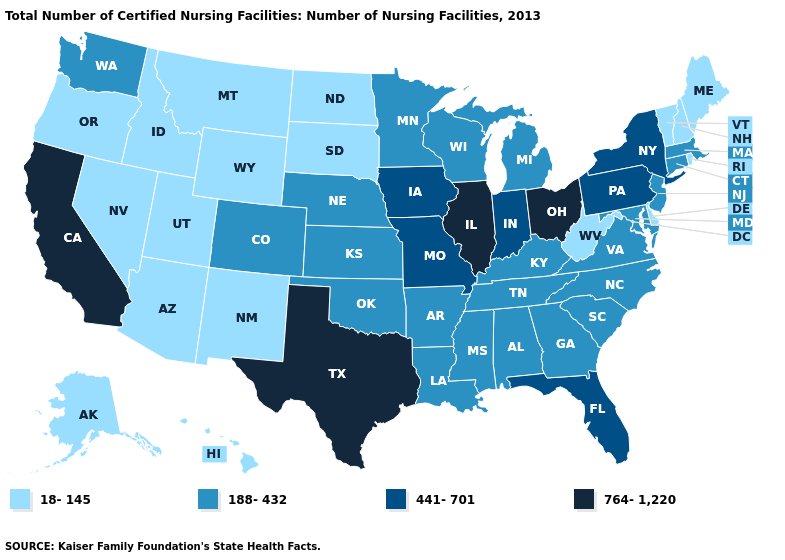What is the value of Rhode Island?
Keep it brief. 18-145. Which states have the lowest value in the Northeast?
Concise answer only. Maine, New Hampshire, Rhode Island, Vermont. Does the first symbol in the legend represent the smallest category?
Concise answer only. Yes. Does Maine have a lower value than Oregon?
Give a very brief answer. No. What is the highest value in the USA?
Answer briefly. 764-1,220. What is the highest value in states that border Iowa?
Short answer required. 764-1,220. What is the value of Indiana?
Keep it brief. 441-701. What is the value of Indiana?
Short answer required. 441-701. What is the highest value in the USA?
Concise answer only. 764-1,220. Among the states that border Wisconsin , which have the lowest value?
Concise answer only. Michigan, Minnesota. Does Nevada have a lower value than Indiana?
Quick response, please. Yes. What is the value of Wisconsin?
Concise answer only. 188-432. Name the states that have a value in the range 764-1,220?
Quick response, please. California, Illinois, Ohio, Texas. Does Texas have the highest value in the South?
Give a very brief answer. Yes. 